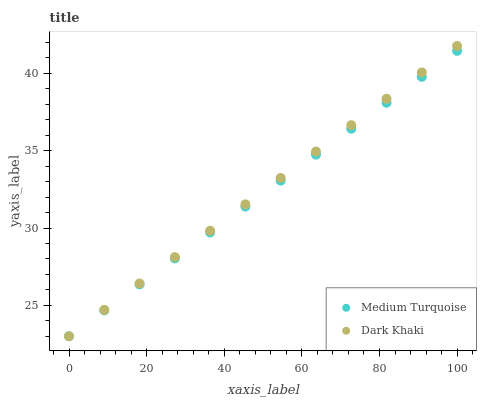Does Medium Turquoise have the minimum area under the curve?
Answer yes or no. Yes. Does Dark Khaki have the maximum area under the curve?
Answer yes or no. Yes. Does Medium Turquoise have the maximum area under the curve?
Answer yes or no. No. Is Dark Khaki the smoothest?
Answer yes or no. Yes. Is Medium Turquoise the roughest?
Answer yes or no. Yes. Is Medium Turquoise the smoothest?
Answer yes or no. No. Does Dark Khaki have the lowest value?
Answer yes or no. Yes. Does Dark Khaki have the highest value?
Answer yes or no. Yes. Does Medium Turquoise have the highest value?
Answer yes or no. No. Does Dark Khaki intersect Medium Turquoise?
Answer yes or no. Yes. Is Dark Khaki less than Medium Turquoise?
Answer yes or no. No. Is Dark Khaki greater than Medium Turquoise?
Answer yes or no. No. 